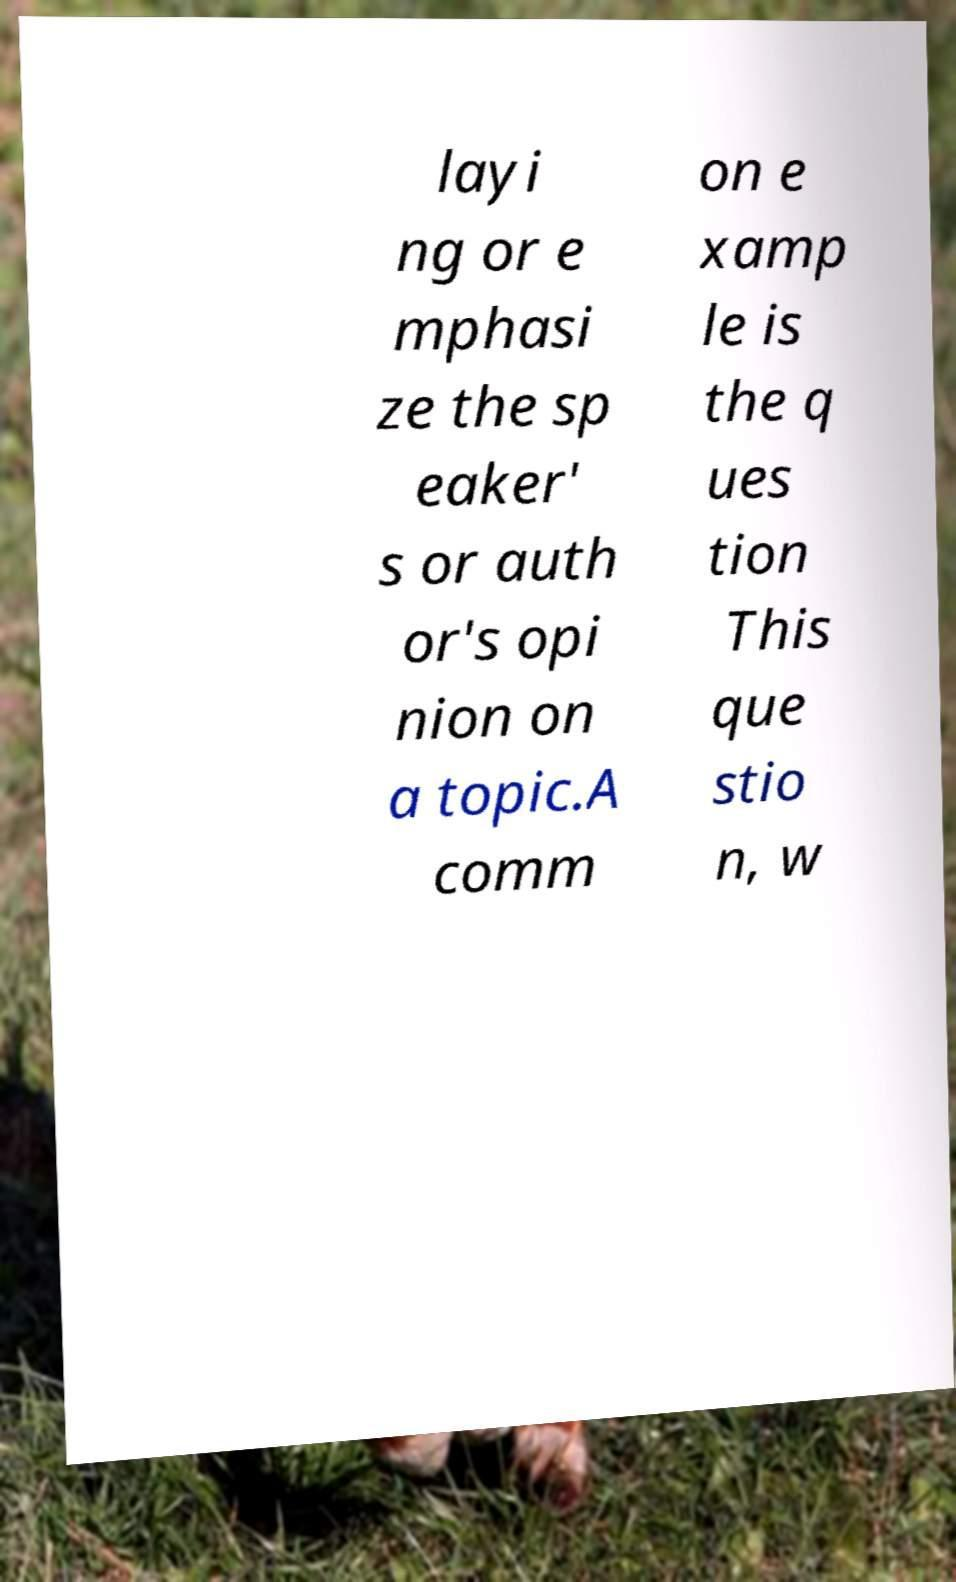Please read and relay the text visible in this image. What does it say? layi ng or e mphasi ze the sp eaker' s or auth or's opi nion on a topic.A comm on e xamp le is the q ues tion This que stio n, w 